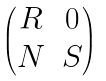Convert formula to latex. <formula><loc_0><loc_0><loc_500><loc_500>\begin{pmatrix} R & 0 \\ N & S \end{pmatrix}</formula> 